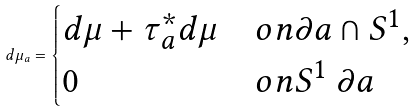Convert formula to latex. <formula><loc_0><loc_0><loc_500><loc_500>d \mu _ { a } = \begin{cases} d \mu + \tau _ { a } ^ { * } d \mu & o n \partial a \cap S ^ { 1 } , \\ 0 & o n S ^ { 1 } \ \partial a \end{cases}</formula> 